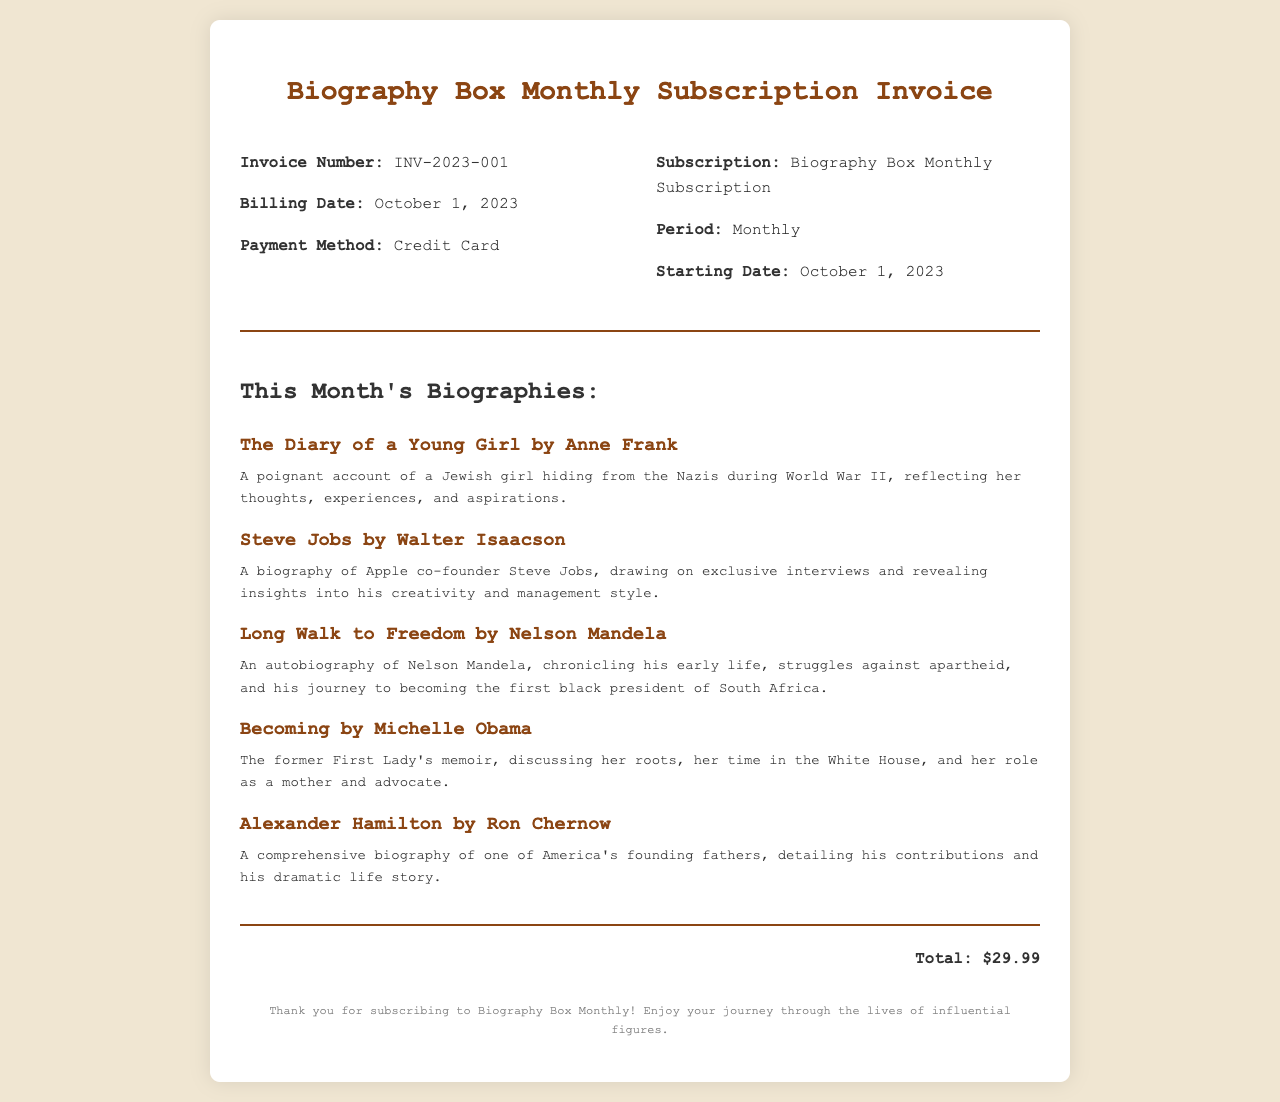What is the invoice number? The invoice number is a unique identifier for the document, found in the top section of the invoice.
Answer: INV-2023-001 What is the billing date? The billing date indicates when the invoice was issued, located in the invoice details section.
Answer: October 1, 2023 How much is the subscription total? The total amount for the subscription can be found at the bottom of the invoice.
Answer: $29.99 Name one book included in this month's biographies. One of the books is listed under the biographies section, showcasing curated titles.
Answer: The Diary of a Young Girl by Anne Frank Who wrote "Steve Jobs"? This question pertains to the authorship of one of the featured books, located in the descriptions.
Answer: Walter Isaacson When does the subscription period start? The starting date of the subscription is specified to inform about the active duration of the invoiced service.
Answer: October 1, 2023 How is the payment made? This information explains the method used to settle the invoice, found in the invoice details section.
Answer: Credit Card What is the name of the subscription service? This refers to the title of the service provided, which is mentioned in the invoice details.
Answer: Biography Box Monthly Subscription Who is the author of "Long Walk to Freedom"? This question asks for the author of one of the significant biographies presented in the document.
Answer: Nelson Mandela 